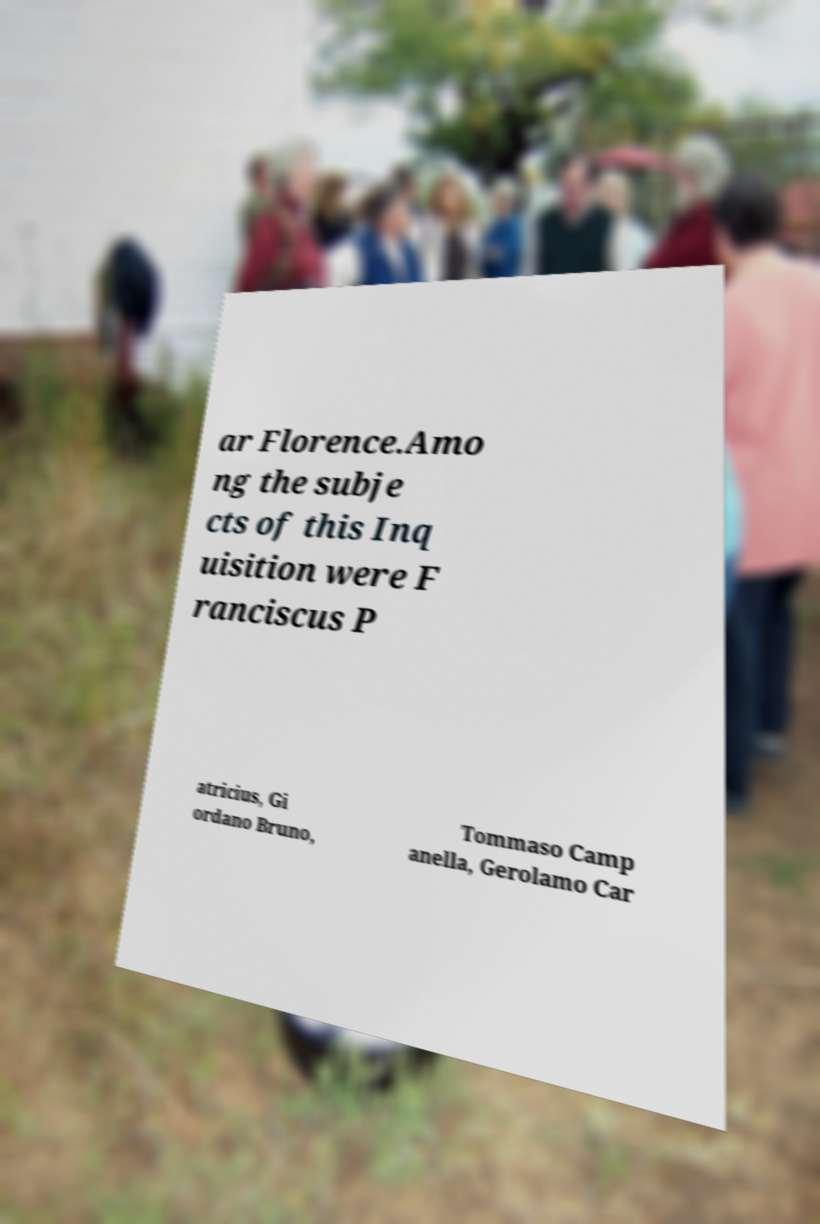For documentation purposes, I need the text within this image transcribed. Could you provide that? ar Florence.Amo ng the subje cts of this Inq uisition were F ranciscus P atricius, Gi ordano Bruno, Tommaso Camp anella, Gerolamo Car 